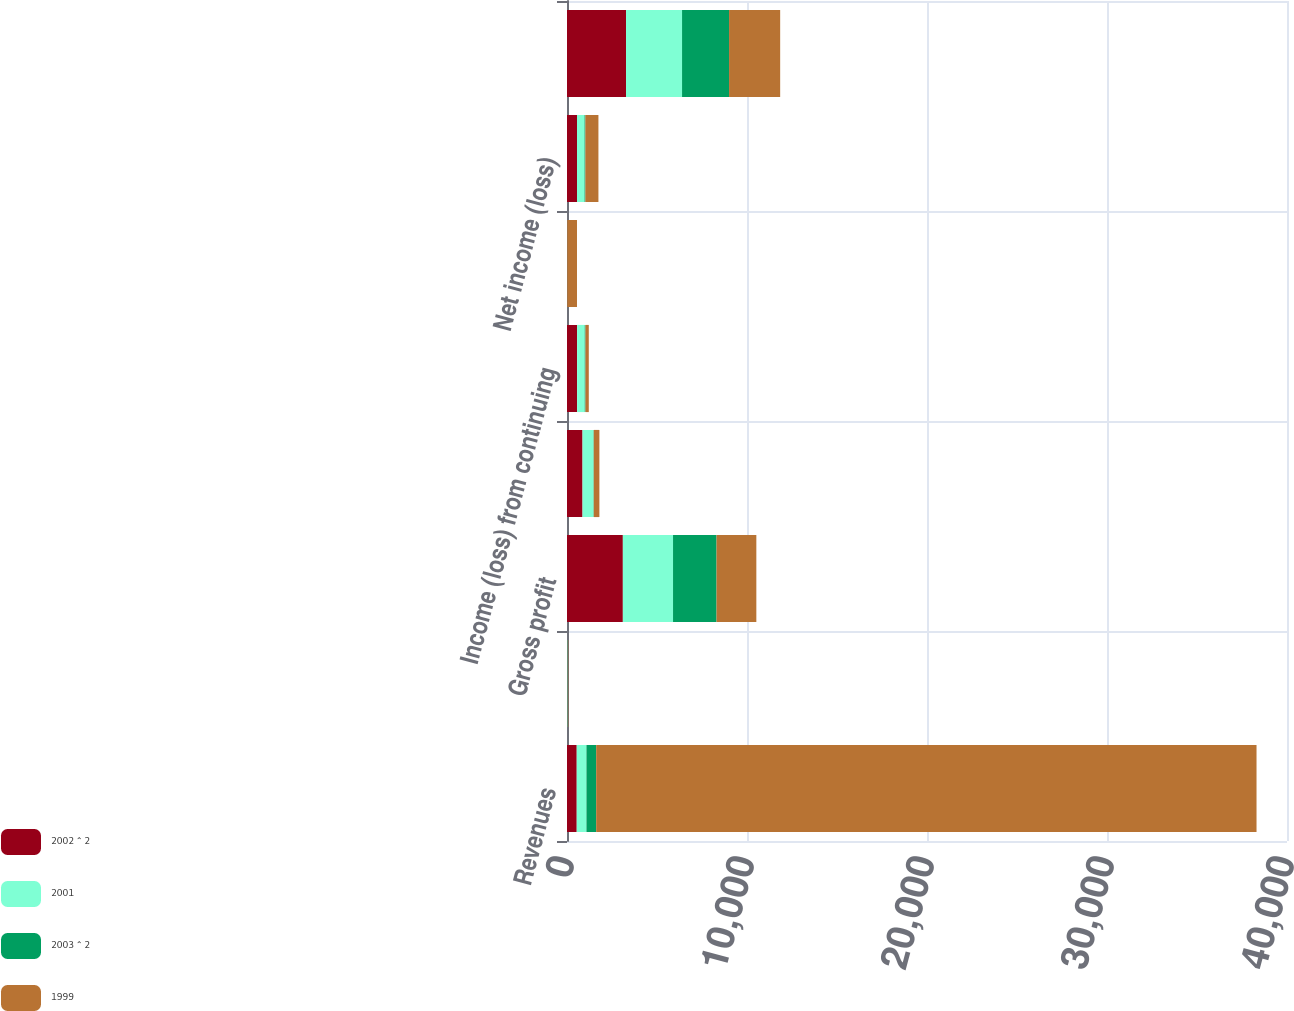Convert chart. <chart><loc_0><loc_0><loc_500><loc_500><stacked_bar_chart><ecel><fcel>Revenues<fcel>Percent change<fcel>Gross profit<fcel>Income from continuing<fcel>Income (loss) from continuing<fcel>Income (loss) from<fcel>Net income (loss)<fcel>Working capital<nl><fcel>2002 ^ 2<fcel>540.4<fcel>14.3<fcel>3102.5<fcel>861.6<fcel>562.1<fcel>6.7<fcel>555.4<fcel>3279.2<nl><fcel>2001<fcel>540.4<fcel>19<fcel>2788.5<fcel>612.3<fcel>421.8<fcel>3.2<fcel>418.6<fcel>3112.8<nl><fcel>2003 ^ 2<fcel>540.4<fcel>14.5<fcel>2417<fcel>14.8<fcel>43.3<fcel>5<fcel>48.3<fcel>2611.5<nl><fcel>1999<fcel>36685.9<fcel>22.4<fcel>2210.9<fcel>310.9<fcel>183.3<fcel>540.4<fcel>723.7<fcel>2839<nl></chart> 